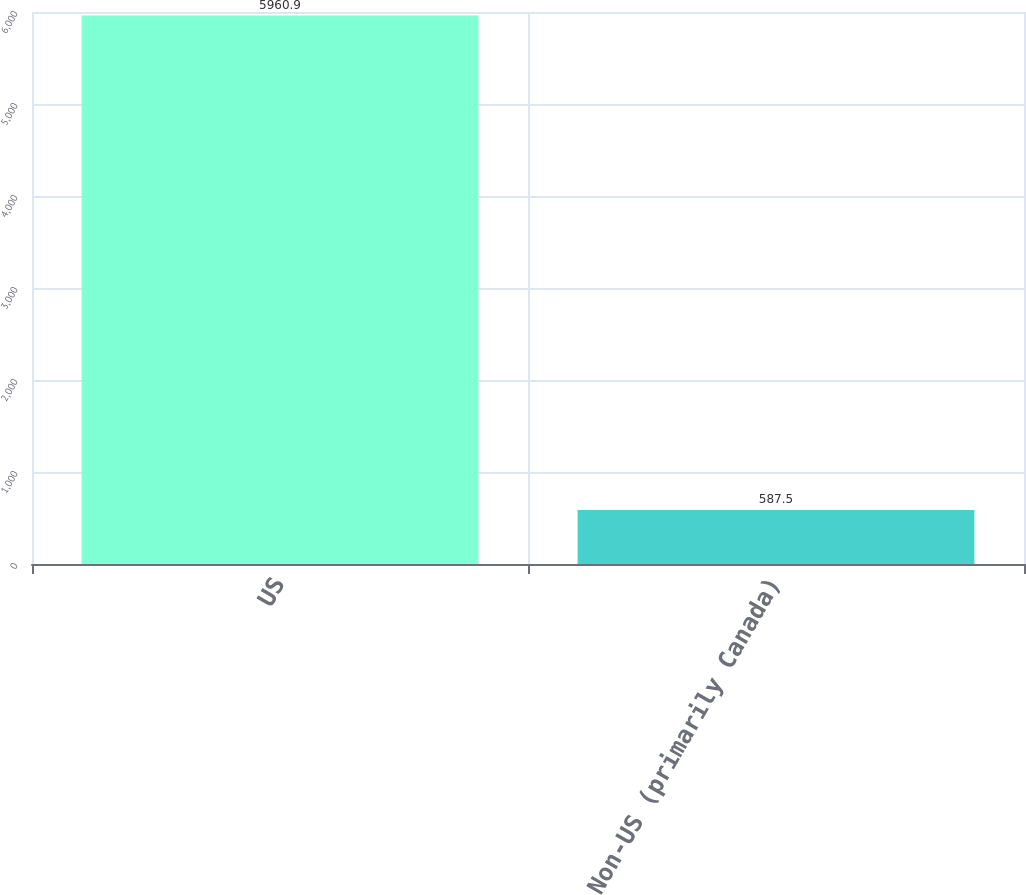<chart> <loc_0><loc_0><loc_500><loc_500><bar_chart><fcel>US<fcel>Non-US (primarily Canada)<nl><fcel>5960.9<fcel>587.5<nl></chart> 